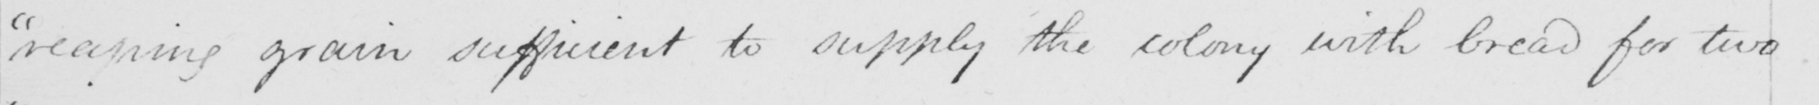Please provide the text content of this handwritten line. reaping grain sufficient to supply the colony with bread for two 